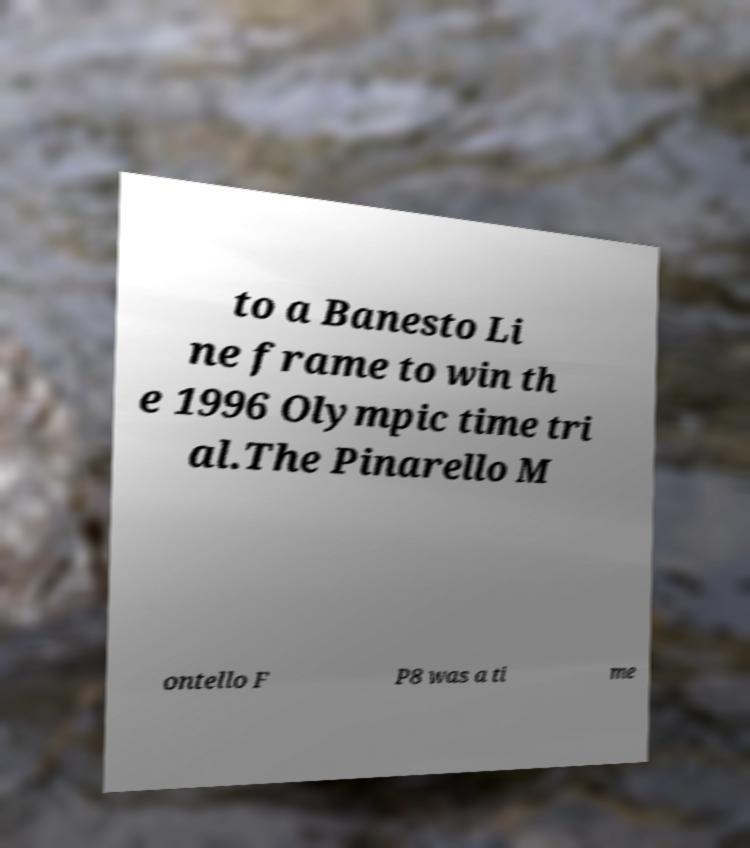What messages or text are displayed in this image? I need them in a readable, typed format. to a Banesto Li ne frame to win th e 1996 Olympic time tri al.The Pinarello M ontello F P8 was a ti me 